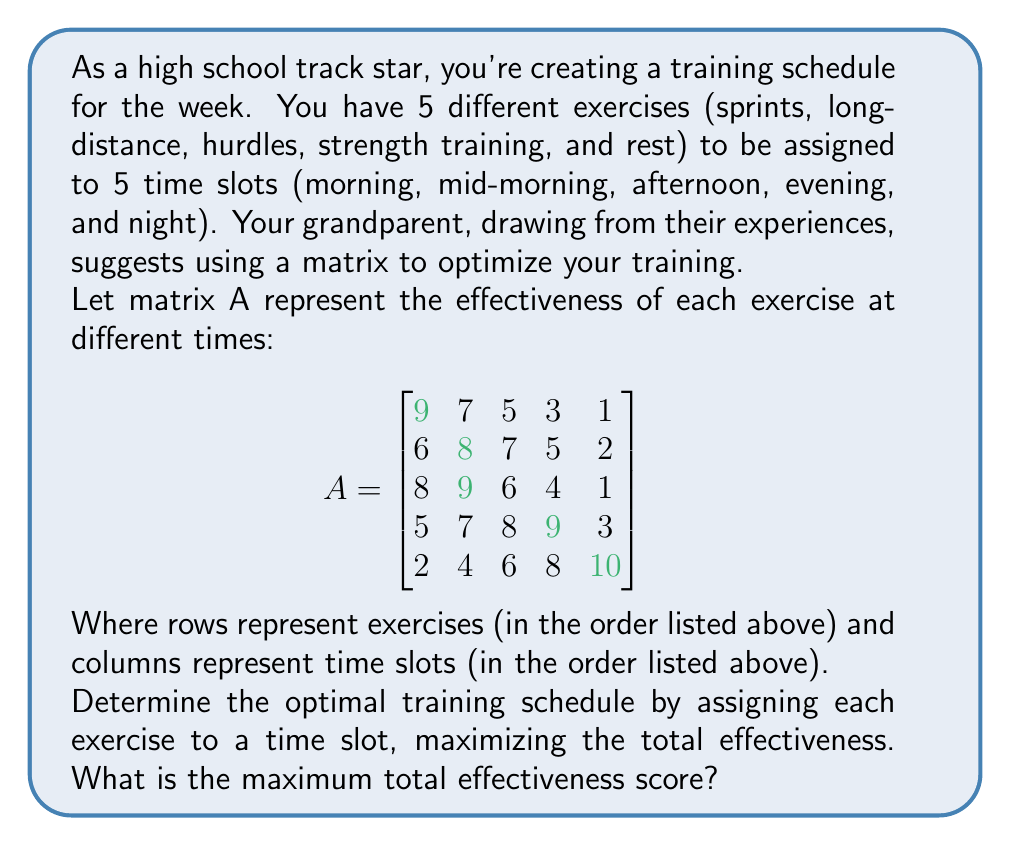What is the answer to this math problem? To solve this problem, we need to find the maximum sum possible by selecting one element from each row and each column of the matrix. This is known as the assignment problem.

Step 1: Observe that we need to choose exactly one element from each row and column.

Step 2: The brute force approach would be to check all possible combinations, but that would be time-consuming. Instead, we can use the Hungarian algorithm or inspection method for this 5x5 matrix.

Step 3: By inspection, we can see that the largest elements in each row are:
- Row 1 (sprints): 9 (morning)
- Row 2 (long-distance): 8 (mid-morning)
- Row 3 (hurdles): 9 (mid-morning)
- Row 4 (strength training): 9 (evening)
- Row 5 (rest): 10 (night)

Step 4: However, we can't choose both 8 and 9 from the mid-morning column. We need to optimize our choices.

Step 5: After careful inspection, the optimal assignment is:
- Sprints: Morning (9)
- Long-distance: Afternoon (7)
- Hurdles: Mid-morning (9)
- Strength training: Evening (9)
- Rest: Night (10)

Step 6: Calculate the total effectiveness:
9 + 7 + 9 + 9 + 10 = 44

Therefore, the maximum total effectiveness score is 44.
Answer: 44 